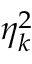<formula> <loc_0><loc_0><loc_500><loc_500>\eta _ { k } ^ { 2 }</formula> 